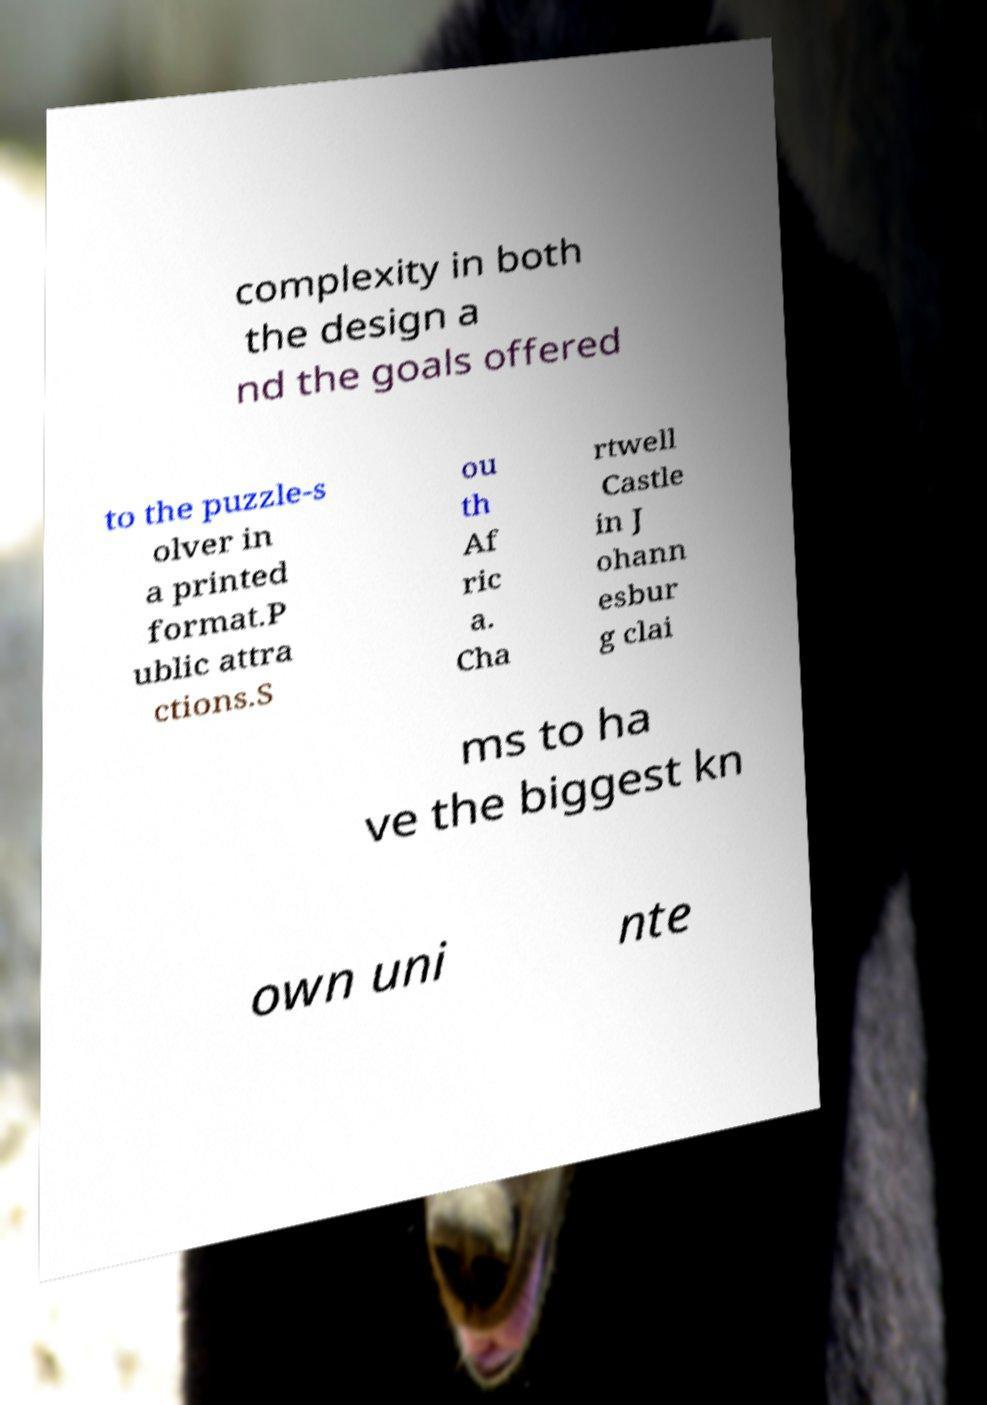What messages or text are displayed in this image? I need them in a readable, typed format. complexity in both the design a nd the goals offered to the puzzle-s olver in a printed format.P ublic attra ctions.S ou th Af ric a. Cha rtwell Castle in J ohann esbur g clai ms to ha ve the biggest kn own uni nte 